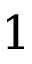<formula> <loc_0><loc_0><loc_500><loc_500>1</formula> 